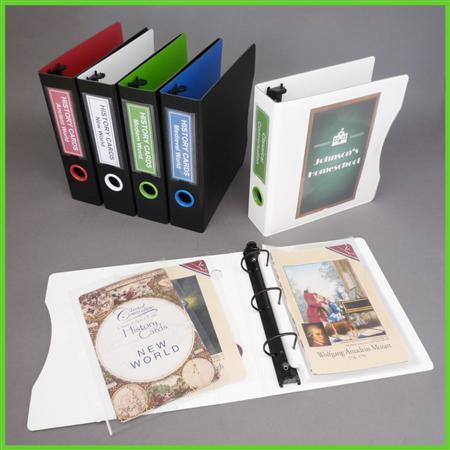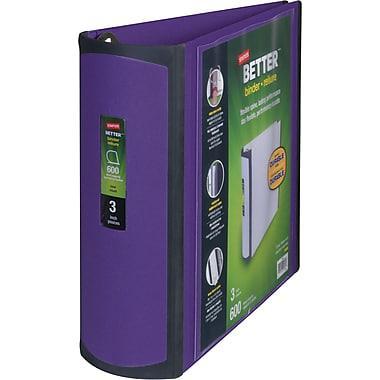The first image is the image on the left, the second image is the image on the right. Examine the images to the left and right. Is the description "The left image contains a single binder, and the right image contains a row of upright binders with circles on the bound edges." accurate? Answer yes or no. No. The first image is the image on the left, the second image is the image on the right. For the images displayed, is the sentence "The right image contains at least four binders standing vertically." factually correct? Answer yes or no. No. 